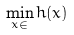<formula> <loc_0><loc_0><loc_500><loc_500>\min _ { x \in \real } h ( x )</formula> 